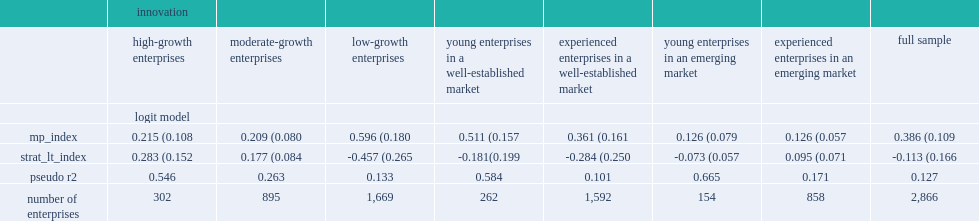How many percent increase in the probability that an enterprise will innovate can a one-point increase in the management practices index causes overall? 0.386 (0.109. How many percent increase in the probability that an low-growth enterprise will innovate can a one-point increase in the management practices index causes? 0.596 (0.180. 